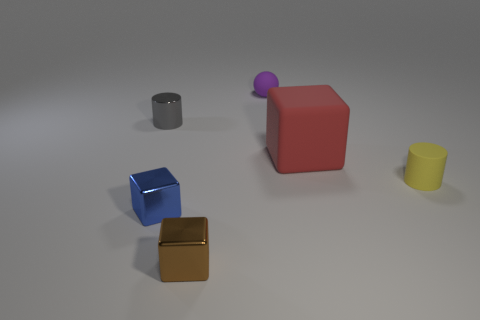Subtract all brown shiny cubes. How many cubes are left? 2 Add 4 matte cubes. How many objects exist? 10 Subtract all yellow cylinders. How many cylinders are left? 1 Subtract all balls. How many objects are left? 5 Subtract all yellow cylinders. Subtract all purple balls. How many cylinders are left? 1 Subtract all blue blocks. How many yellow cylinders are left? 1 Subtract all red cubes. Subtract all tiny yellow rubber cylinders. How many objects are left? 4 Add 5 tiny blue things. How many tiny blue things are left? 6 Add 4 brown objects. How many brown objects exist? 5 Subtract 0 cyan cylinders. How many objects are left? 6 